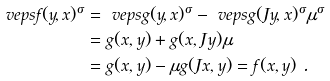Convert formula to latex. <formula><loc_0><loc_0><loc_500><loc_500>\ v e p s f ( y , x ) ^ { \sigma } & = \ v e p s g ( y , x ) ^ { \sigma } - \ v e p s g ( J y , x ) ^ { \sigma } \mu ^ { \sigma } \\ & = g ( x , y ) + g ( x , J y ) \mu \\ & = g ( x , y ) - \mu g ( J x , y ) = f ( x , y ) \ .</formula> 